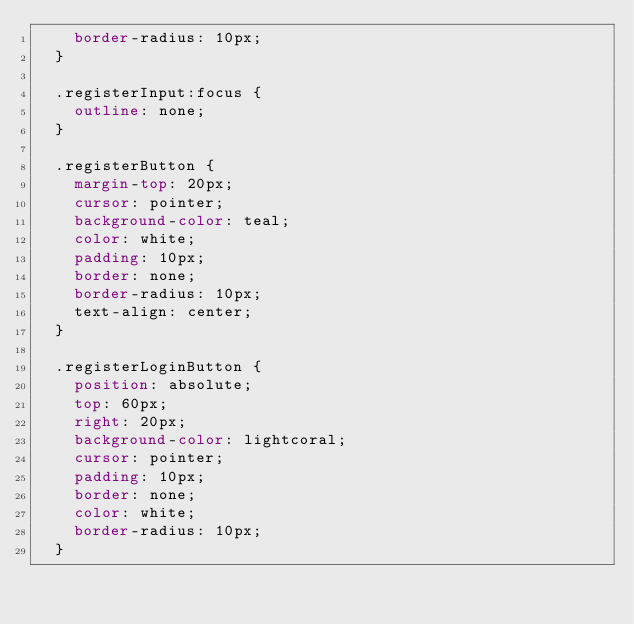<code> <loc_0><loc_0><loc_500><loc_500><_CSS_>    border-radius: 10px;
  }
  
  .registerInput:focus {
    outline: none;
  }
  
  .registerButton {
    margin-top: 20px;
    cursor: pointer;
    background-color: teal;
    color: white;
    padding: 10px;
    border: none;
    border-radius: 10px;
    text-align: center;
  }
  
  .registerLoginButton {
    position: absolute;
    top: 60px;
    right: 20px;
    background-color: lightcoral;
    cursor: pointer;
    padding: 10px;
    border: none;
    color: white;
    border-radius: 10px;
  }</code> 